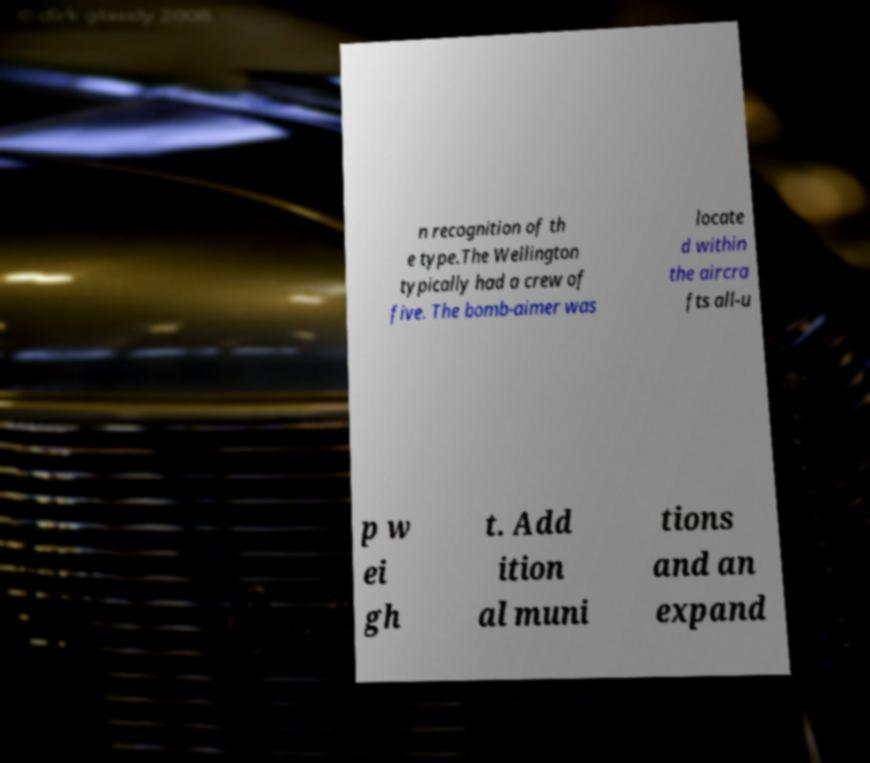For documentation purposes, I need the text within this image transcribed. Could you provide that? n recognition of th e type.The Wellington typically had a crew of five. The bomb-aimer was locate d within the aircra fts all-u p w ei gh t. Add ition al muni tions and an expand 